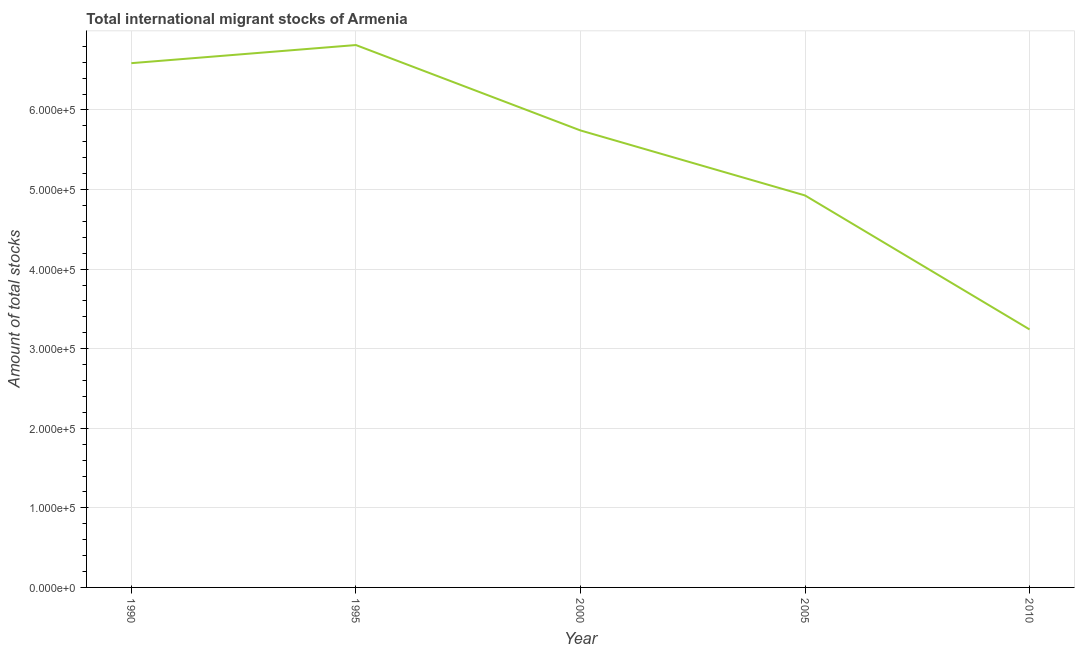What is the total number of international migrant stock in 1995?
Make the answer very short. 6.82e+05. Across all years, what is the maximum total number of international migrant stock?
Give a very brief answer. 6.82e+05. Across all years, what is the minimum total number of international migrant stock?
Provide a short and direct response. 3.24e+05. In which year was the total number of international migrant stock maximum?
Ensure brevity in your answer.  1995. In which year was the total number of international migrant stock minimum?
Offer a terse response. 2010. What is the sum of the total number of international migrant stock?
Make the answer very short. 2.73e+06. What is the difference between the total number of international migrant stock in 2005 and 2010?
Provide a short and direct response. 1.68e+05. What is the average total number of international migrant stock per year?
Keep it short and to the point. 5.46e+05. What is the median total number of international migrant stock?
Give a very brief answer. 5.74e+05. What is the ratio of the total number of international migrant stock in 1995 to that in 2010?
Your answer should be very brief. 2.1. Is the total number of international migrant stock in 1990 less than that in 1995?
Make the answer very short. Yes. Is the difference between the total number of international migrant stock in 2000 and 2010 greater than the difference between any two years?
Make the answer very short. No. What is the difference between the highest and the second highest total number of international migrant stock?
Provide a short and direct response. 2.28e+04. Is the sum of the total number of international migrant stock in 2000 and 2010 greater than the maximum total number of international migrant stock across all years?
Ensure brevity in your answer.  Yes. What is the difference between the highest and the lowest total number of international migrant stock?
Provide a succinct answer. 3.57e+05. In how many years, is the total number of international migrant stock greater than the average total number of international migrant stock taken over all years?
Your answer should be very brief. 3. Does the total number of international migrant stock monotonically increase over the years?
Provide a succinct answer. No. How many lines are there?
Keep it short and to the point. 1. How many years are there in the graph?
Keep it short and to the point. 5. What is the title of the graph?
Ensure brevity in your answer.  Total international migrant stocks of Armenia. What is the label or title of the X-axis?
Offer a terse response. Year. What is the label or title of the Y-axis?
Your answer should be compact. Amount of total stocks. What is the Amount of total stocks of 1990?
Your answer should be compact. 6.59e+05. What is the Amount of total stocks in 1995?
Ensure brevity in your answer.  6.82e+05. What is the Amount of total stocks in 2000?
Provide a succinct answer. 5.74e+05. What is the Amount of total stocks in 2005?
Ensure brevity in your answer.  4.93e+05. What is the Amount of total stocks of 2010?
Your answer should be very brief. 3.24e+05. What is the difference between the Amount of total stocks in 1990 and 1995?
Provide a short and direct response. -2.28e+04. What is the difference between the Amount of total stocks in 1990 and 2000?
Ensure brevity in your answer.  8.46e+04. What is the difference between the Amount of total stocks in 1990 and 2005?
Keep it short and to the point. 1.66e+05. What is the difference between the Amount of total stocks in 1990 and 2010?
Ensure brevity in your answer.  3.35e+05. What is the difference between the Amount of total stocks in 1995 and 2000?
Your answer should be very brief. 1.07e+05. What is the difference between the Amount of total stocks in 1995 and 2005?
Offer a terse response. 1.89e+05. What is the difference between the Amount of total stocks in 1995 and 2010?
Make the answer very short. 3.57e+05. What is the difference between the Amount of total stocks in 2000 and 2005?
Offer a very short reply. 8.17e+04. What is the difference between the Amount of total stocks in 2000 and 2010?
Ensure brevity in your answer.  2.50e+05. What is the difference between the Amount of total stocks in 2005 and 2010?
Give a very brief answer. 1.68e+05. What is the ratio of the Amount of total stocks in 1990 to that in 1995?
Your response must be concise. 0.97. What is the ratio of the Amount of total stocks in 1990 to that in 2000?
Your answer should be very brief. 1.15. What is the ratio of the Amount of total stocks in 1990 to that in 2005?
Ensure brevity in your answer.  1.34. What is the ratio of the Amount of total stocks in 1990 to that in 2010?
Keep it short and to the point. 2.03. What is the ratio of the Amount of total stocks in 1995 to that in 2000?
Your answer should be compact. 1.19. What is the ratio of the Amount of total stocks in 1995 to that in 2005?
Ensure brevity in your answer.  1.38. What is the ratio of the Amount of total stocks in 1995 to that in 2010?
Offer a very short reply. 2.1. What is the ratio of the Amount of total stocks in 2000 to that in 2005?
Your response must be concise. 1.17. What is the ratio of the Amount of total stocks in 2000 to that in 2010?
Give a very brief answer. 1.77. What is the ratio of the Amount of total stocks in 2005 to that in 2010?
Your answer should be compact. 1.52. 